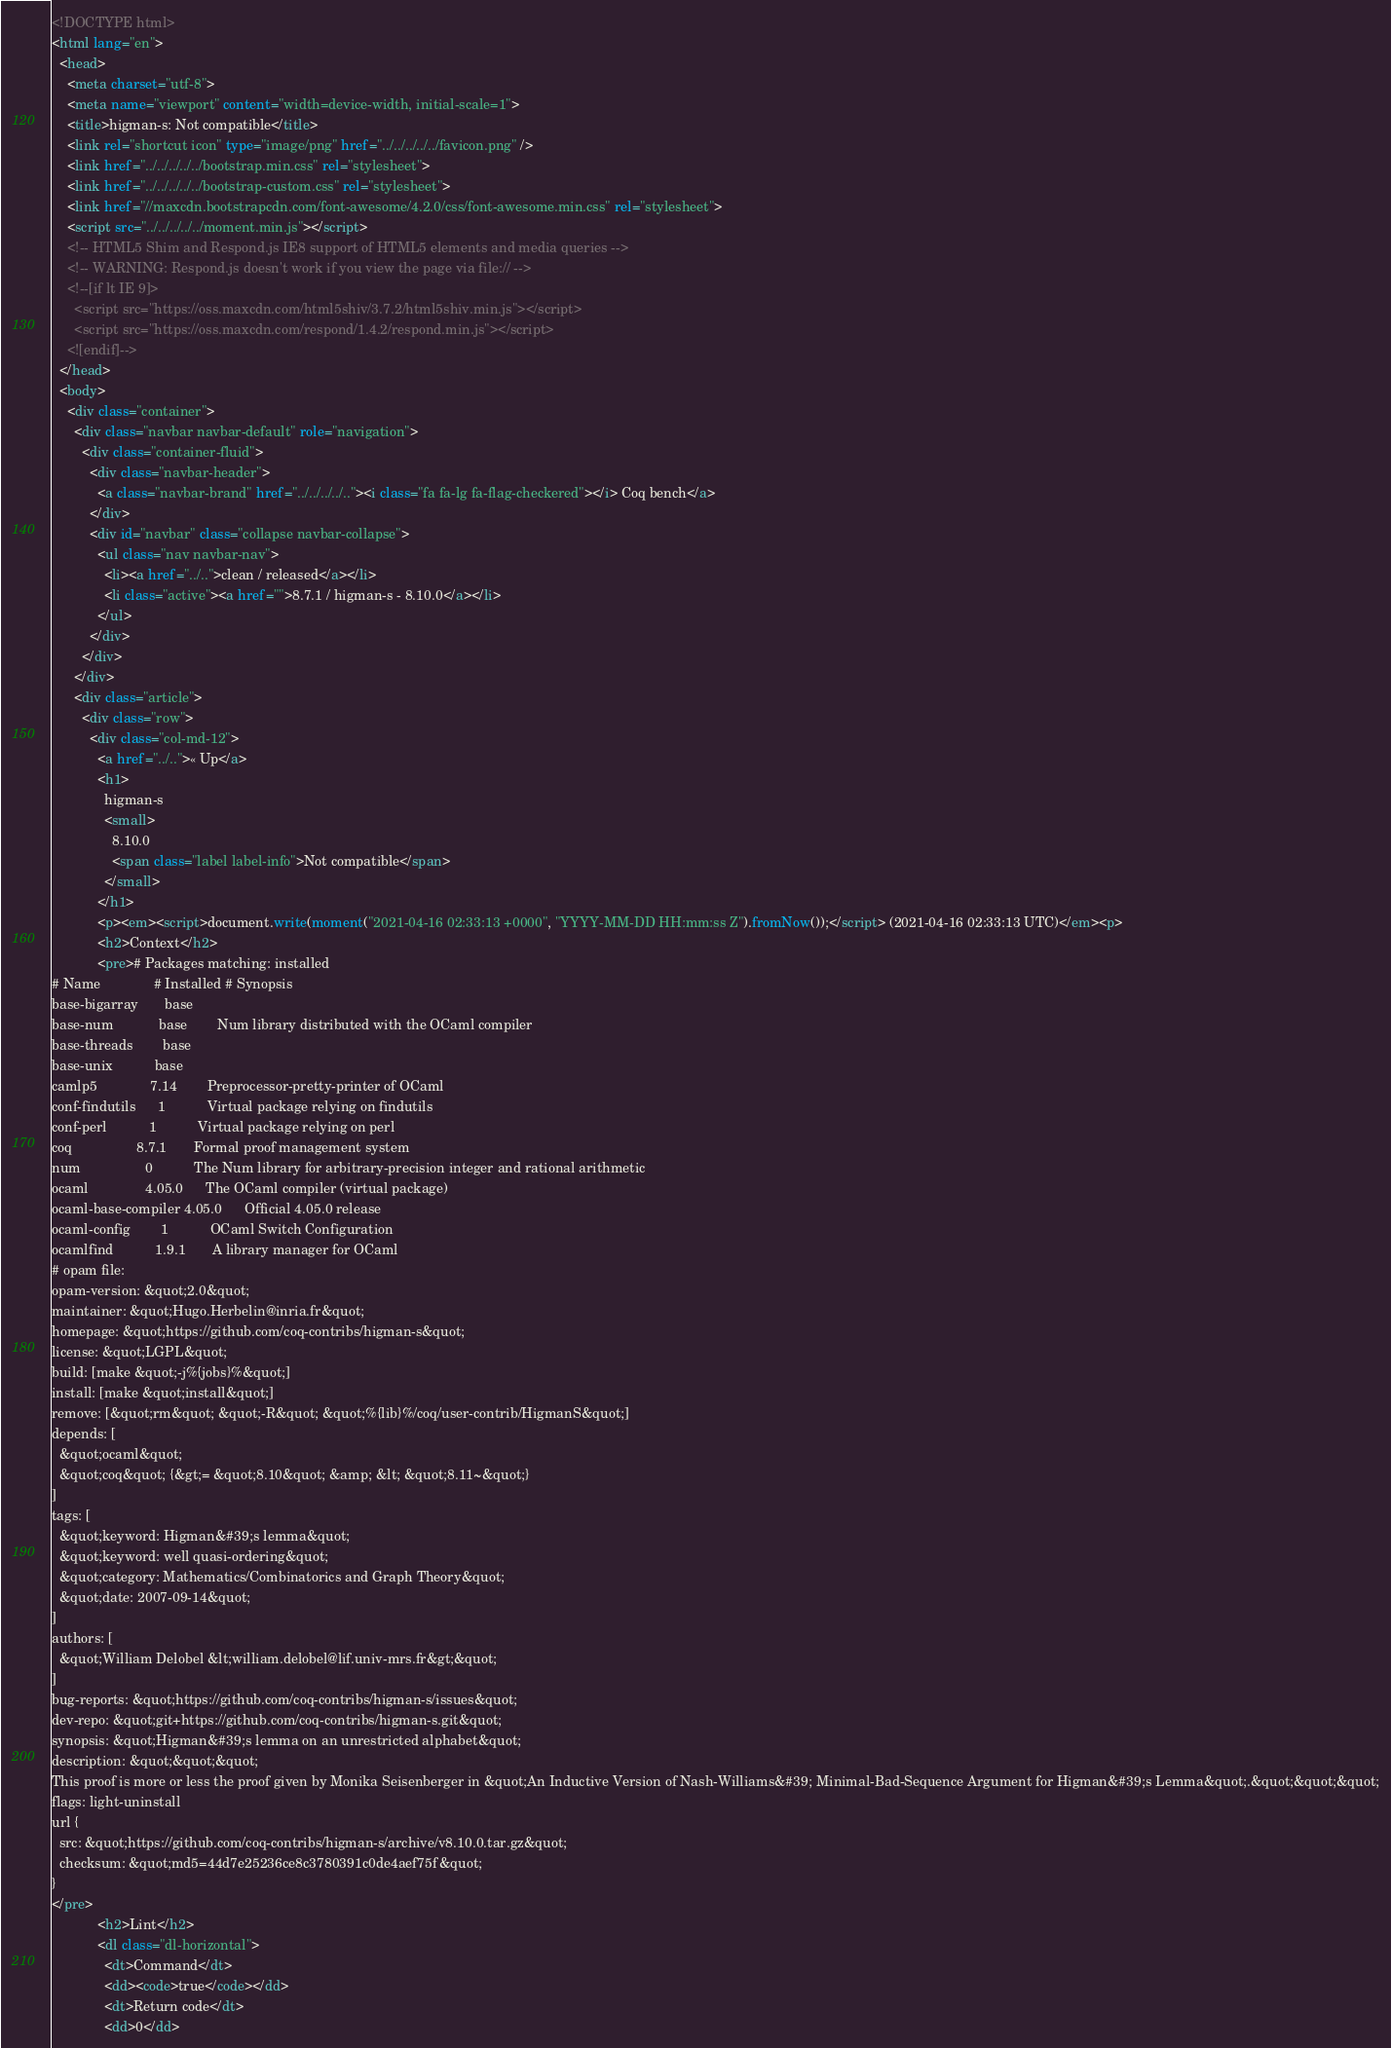Convert code to text. <code><loc_0><loc_0><loc_500><loc_500><_HTML_><!DOCTYPE html>
<html lang="en">
  <head>
    <meta charset="utf-8">
    <meta name="viewport" content="width=device-width, initial-scale=1">
    <title>higman-s: Not compatible</title>
    <link rel="shortcut icon" type="image/png" href="../../../../../favicon.png" />
    <link href="../../../../../bootstrap.min.css" rel="stylesheet">
    <link href="../../../../../bootstrap-custom.css" rel="stylesheet">
    <link href="//maxcdn.bootstrapcdn.com/font-awesome/4.2.0/css/font-awesome.min.css" rel="stylesheet">
    <script src="../../../../../moment.min.js"></script>
    <!-- HTML5 Shim and Respond.js IE8 support of HTML5 elements and media queries -->
    <!-- WARNING: Respond.js doesn't work if you view the page via file:// -->
    <!--[if lt IE 9]>
      <script src="https://oss.maxcdn.com/html5shiv/3.7.2/html5shiv.min.js"></script>
      <script src="https://oss.maxcdn.com/respond/1.4.2/respond.min.js"></script>
    <![endif]-->
  </head>
  <body>
    <div class="container">
      <div class="navbar navbar-default" role="navigation">
        <div class="container-fluid">
          <div class="navbar-header">
            <a class="navbar-brand" href="../../../../.."><i class="fa fa-lg fa-flag-checkered"></i> Coq bench</a>
          </div>
          <div id="navbar" class="collapse navbar-collapse">
            <ul class="nav navbar-nav">
              <li><a href="../..">clean / released</a></li>
              <li class="active"><a href="">8.7.1 / higman-s - 8.10.0</a></li>
            </ul>
          </div>
        </div>
      </div>
      <div class="article">
        <div class="row">
          <div class="col-md-12">
            <a href="../..">« Up</a>
            <h1>
              higman-s
              <small>
                8.10.0
                <span class="label label-info">Not compatible</span>
              </small>
            </h1>
            <p><em><script>document.write(moment("2021-04-16 02:33:13 +0000", "YYYY-MM-DD HH:mm:ss Z").fromNow());</script> (2021-04-16 02:33:13 UTC)</em><p>
            <h2>Context</h2>
            <pre># Packages matching: installed
# Name              # Installed # Synopsis
base-bigarray       base
base-num            base        Num library distributed with the OCaml compiler
base-threads        base
base-unix           base
camlp5              7.14        Preprocessor-pretty-printer of OCaml
conf-findutils      1           Virtual package relying on findutils
conf-perl           1           Virtual package relying on perl
coq                 8.7.1       Formal proof management system
num                 0           The Num library for arbitrary-precision integer and rational arithmetic
ocaml               4.05.0      The OCaml compiler (virtual package)
ocaml-base-compiler 4.05.0      Official 4.05.0 release
ocaml-config        1           OCaml Switch Configuration
ocamlfind           1.9.1       A library manager for OCaml
# opam file:
opam-version: &quot;2.0&quot;
maintainer: &quot;Hugo.Herbelin@inria.fr&quot;
homepage: &quot;https://github.com/coq-contribs/higman-s&quot;
license: &quot;LGPL&quot;
build: [make &quot;-j%{jobs}%&quot;]
install: [make &quot;install&quot;]
remove: [&quot;rm&quot; &quot;-R&quot; &quot;%{lib}%/coq/user-contrib/HigmanS&quot;]
depends: [
  &quot;ocaml&quot;
  &quot;coq&quot; {&gt;= &quot;8.10&quot; &amp; &lt; &quot;8.11~&quot;}
]
tags: [
  &quot;keyword: Higman&#39;s lemma&quot;
  &quot;keyword: well quasi-ordering&quot;
  &quot;category: Mathematics/Combinatorics and Graph Theory&quot;
  &quot;date: 2007-09-14&quot;
]
authors: [
  &quot;William Delobel &lt;william.delobel@lif.univ-mrs.fr&gt;&quot;
]
bug-reports: &quot;https://github.com/coq-contribs/higman-s/issues&quot;
dev-repo: &quot;git+https://github.com/coq-contribs/higman-s.git&quot;
synopsis: &quot;Higman&#39;s lemma on an unrestricted alphabet&quot;
description: &quot;&quot;&quot;
This proof is more or less the proof given by Monika Seisenberger in &quot;An Inductive Version of Nash-Williams&#39; Minimal-Bad-Sequence Argument for Higman&#39;s Lemma&quot;.&quot;&quot;&quot;
flags: light-uninstall
url {
  src: &quot;https://github.com/coq-contribs/higman-s/archive/v8.10.0.tar.gz&quot;
  checksum: &quot;md5=44d7e25236ce8c3780391c0de4aef75f&quot;
}
</pre>
            <h2>Lint</h2>
            <dl class="dl-horizontal">
              <dt>Command</dt>
              <dd><code>true</code></dd>
              <dt>Return code</dt>
              <dd>0</dd></code> 